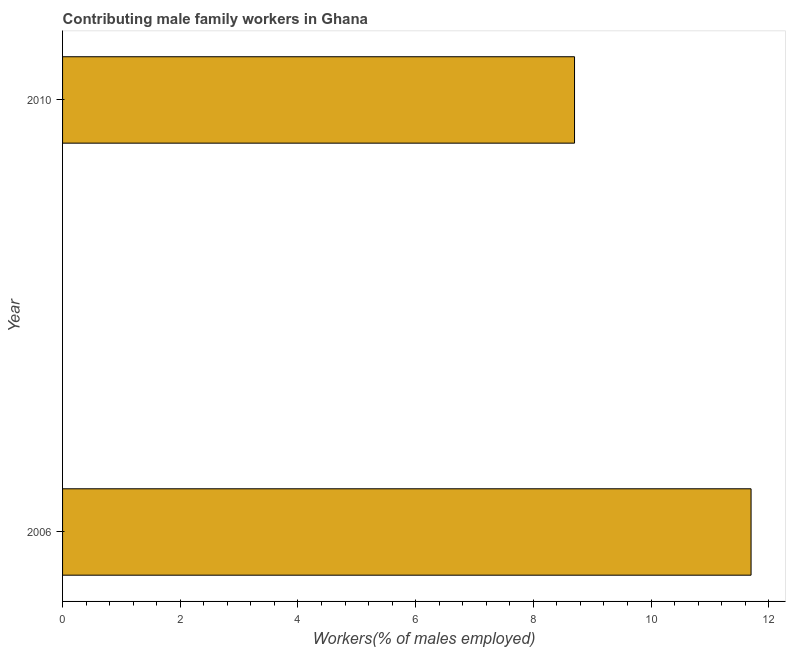Does the graph contain any zero values?
Provide a short and direct response. No. Does the graph contain grids?
Offer a terse response. No. What is the title of the graph?
Offer a terse response. Contributing male family workers in Ghana. What is the label or title of the X-axis?
Your answer should be compact. Workers(% of males employed). What is the contributing male family workers in 2010?
Your answer should be compact. 8.7. Across all years, what is the maximum contributing male family workers?
Provide a short and direct response. 11.7. Across all years, what is the minimum contributing male family workers?
Keep it short and to the point. 8.7. In which year was the contributing male family workers maximum?
Give a very brief answer. 2006. In which year was the contributing male family workers minimum?
Your response must be concise. 2010. What is the sum of the contributing male family workers?
Keep it short and to the point. 20.4. What is the median contributing male family workers?
Ensure brevity in your answer.  10.2. In how many years, is the contributing male family workers greater than 6.4 %?
Your answer should be compact. 2. Do a majority of the years between 2006 and 2010 (inclusive) have contributing male family workers greater than 1.6 %?
Your answer should be compact. Yes. What is the ratio of the contributing male family workers in 2006 to that in 2010?
Provide a short and direct response. 1.34. Is the contributing male family workers in 2006 less than that in 2010?
Provide a succinct answer. No. In how many years, is the contributing male family workers greater than the average contributing male family workers taken over all years?
Make the answer very short. 1. How many bars are there?
Your answer should be very brief. 2. Are all the bars in the graph horizontal?
Keep it short and to the point. Yes. How many years are there in the graph?
Provide a short and direct response. 2. Are the values on the major ticks of X-axis written in scientific E-notation?
Give a very brief answer. No. What is the Workers(% of males employed) in 2006?
Give a very brief answer. 11.7. What is the Workers(% of males employed) in 2010?
Make the answer very short. 8.7. What is the difference between the Workers(% of males employed) in 2006 and 2010?
Make the answer very short. 3. What is the ratio of the Workers(% of males employed) in 2006 to that in 2010?
Ensure brevity in your answer.  1.34. 